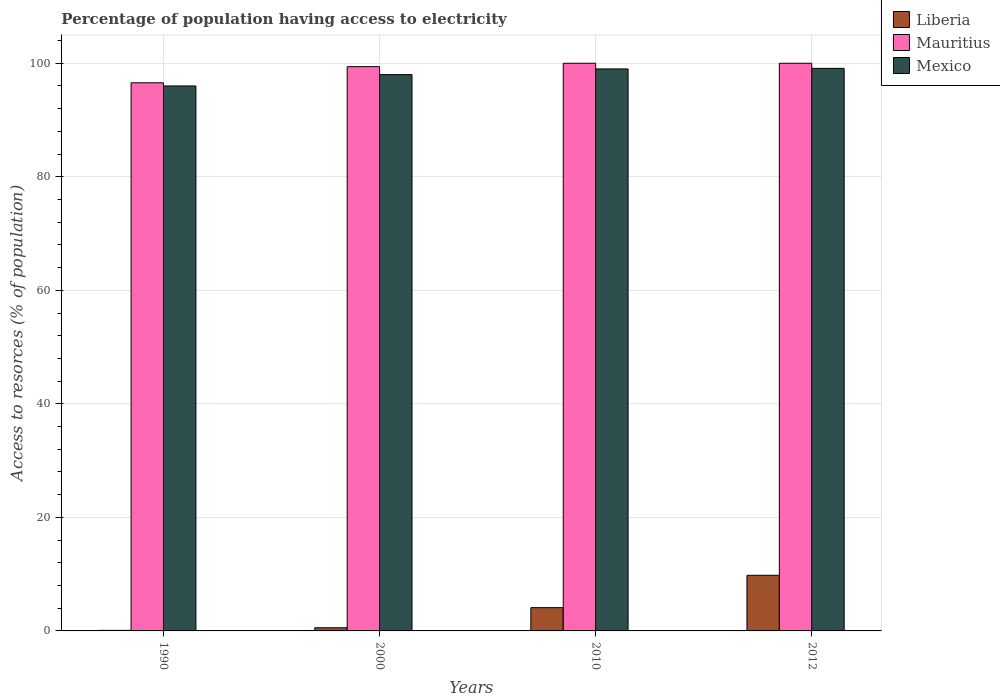How many different coloured bars are there?
Offer a very short reply. 3. How many groups of bars are there?
Provide a short and direct response. 4. Are the number of bars per tick equal to the number of legend labels?
Ensure brevity in your answer.  Yes. Are the number of bars on each tick of the X-axis equal?
Your answer should be compact. Yes. How many bars are there on the 3rd tick from the left?
Ensure brevity in your answer.  3. How many bars are there on the 4th tick from the right?
Keep it short and to the point. 3. What is the label of the 3rd group of bars from the left?
Provide a succinct answer. 2010. What is the percentage of population having access to electricity in Mauritius in 2000?
Make the answer very short. 99.4. Across all years, what is the maximum percentage of population having access to electricity in Mexico?
Make the answer very short. 99.1. Across all years, what is the minimum percentage of population having access to electricity in Mexico?
Give a very brief answer. 96. What is the total percentage of population having access to electricity in Liberia in the graph?
Offer a terse response. 14.56. What is the difference between the percentage of population having access to electricity in Mauritius in 1990 and that in 2012?
Your response must be concise. -3.44. What is the difference between the percentage of population having access to electricity in Mexico in 2010 and the percentage of population having access to electricity in Liberia in 2012?
Offer a terse response. 89.2. What is the average percentage of population having access to electricity in Mexico per year?
Offer a terse response. 98.03. In the year 2010, what is the difference between the percentage of population having access to electricity in Mauritius and percentage of population having access to electricity in Liberia?
Offer a very short reply. 95.9. In how many years, is the percentage of population having access to electricity in Mauritius greater than 32 %?
Your response must be concise. 4. What is the ratio of the percentage of population having access to electricity in Mexico in 2000 to that in 2012?
Your answer should be compact. 0.99. Is the difference between the percentage of population having access to electricity in Mauritius in 1990 and 2010 greater than the difference between the percentage of population having access to electricity in Liberia in 1990 and 2010?
Ensure brevity in your answer.  Yes. What is the difference between the highest and the second highest percentage of population having access to electricity in Mexico?
Your answer should be compact. 0.1. What is the difference between the highest and the lowest percentage of population having access to electricity in Mauritius?
Your answer should be very brief. 3.44. What does the 3rd bar from the right in 2012 represents?
Your answer should be compact. Liberia. How many bars are there?
Ensure brevity in your answer.  12. How many years are there in the graph?
Your answer should be very brief. 4. Does the graph contain grids?
Provide a succinct answer. Yes. How many legend labels are there?
Offer a terse response. 3. What is the title of the graph?
Provide a short and direct response. Percentage of population having access to electricity. Does "Poland" appear as one of the legend labels in the graph?
Provide a short and direct response. No. What is the label or title of the X-axis?
Offer a terse response. Years. What is the label or title of the Y-axis?
Give a very brief answer. Access to resorces (% of population). What is the Access to resorces (% of population) in Mauritius in 1990?
Your answer should be very brief. 96.56. What is the Access to resorces (% of population) of Mexico in 1990?
Provide a succinct answer. 96. What is the Access to resorces (% of population) in Liberia in 2000?
Your answer should be very brief. 0.56. What is the Access to resorces (% of population) in Mauritius in 2000?
Make the answer very short. 99.4. What is the Access to resorces (% of population) in Mexico in 2010?
Your answer should be compact. 99. What is the Access to resorces (% of population) of Liberia in 2012?
Keep it short and to the point. 9.8. What is the Access to resorces (% of population) of Mauritius in 2012?
Keep it short and to the point. 100. What is the Access to resorces (% of population) in Mexico in 2012?
Make the answer very short. 99.1. Across all years, what is the maximum Access to resorces (% of population) of Liberia?
Your answer should be very brief. 9.8. Across all years, what is the maximum Access to resorces (% of population) of Mexico?
Keep it short and to the point. 99.1. Across all years, what is the minimum Access to resorces (% of population) of Liberia?
Offer a terse response. 0.1. Across all years, what is the minimum Access to resorces (% of population) of Mauritius?
Offer a very short reply. 96.56. Across all years, what is the minimum Access to resorces (% of population) of Mexico?
Your response must be concise. 96. What is the total Access to resorces (% of population) of Liberia in the graph?
Make the answer very short. 14.56. What is the total Access to resorces (% of population) in Mauritius in the graph?
Your answer should be compact. 395.96. What is the total Access to resorces (% of population) in Mexico in the graph?
Your answer should be compact. 392.1. What is the difference between the Access to resorces (% of population) of Liberia in 1990 and that in 2000?
Offer a very short reply. -0.46. What is the difference between the Access to resorces (% of population) in Mauritius in 1990 and that in 2000?
Offer a terse response. -2.84. What is the difference between the Access to resorces (% of population) in Mexico in 1990 and that in 2000?
Make the answer very short. -2. What is the difference between the Access to resorces (% of population) in Liberia in 1990 and that in 2010?
Offer a very short reply. -4. What is the difference between the Access to resorces (% of population) in Mauritius in 1990 and that in 2010?
Your answer should be compact. -3.44. What is the difference between the Access to resorces (% of population) of Liberia in 1990 and that in 2012?
Ensure brevity in your answer.  -9.7. What is the difference between the Access to resorces (% of population) of Mauritius in 1990 and that in 2012?
Keep it short and to the point. -3.44. What is the difference between the Access to resorces (% of population) in Mexico in 1990 and that in 2012?
Provide a succinct answer. -3.1. What is the difference between the Access to resorces (% of population) of Liberia in 2000 and that in 2010?
Offer a terse response. -3.54. What is the difference between the Access to resorces (% of population) of Mauritius in 2000 and that in 2010?
Keep it short and to the point. -0.6. What is the difference between the Access to resorces (% of population) of Mexico in 2000 and that in 2010?
Provide a short and direct response. -1. What is the difference between the Access to resorces (% of population) in Liberia in 2000 and that in 2012?
Make the answer very short. -9.24. What is the difference between the Access to resorces (% of population) of Mauritius in 2000 and that in 2012?
Offer a very short reply. -0.6. What is the difference between the Access to resorces (% of population) in Liberia in 1990 and the Access to resorces (% of population) in Mauritius in 2000?
Your answer should be very brief. -99.3. What is the difference between the Access to resorces (% of population) in Liberia in 1990 and the Access to resorces (% of population) in Mexico in 2000?
Your answer should be very brief. -97.9. What is the difference between the Access to resorces (% of population) of Mauritius in 1990 and the Access to resorces (% of population) of Mexico in 2000?
Offer a terse response. -1.44. What is the difference between the Access to resorces (% of population) of Liberia in 1990 and the Access to resorces (% of population) of Mauritius in 2010?
Your answer should be compact. -99.9. What is the difference between the Access to resorces (% of population) in Liberia in 1990 and the Access to resorces (% of population) in Mexico in 2010?
Your response must be concise. -98.9. What is the difference between the Access to resorces (% of population) in Mauritius in 1990 and the Access to resorces (% of population) in Mexico in 2010?
Offer a very short reply. -2.44. What is the difference between the Access to resorces (% of population) in Liberia in 1990 and the Access to resorces (% of population) in Mauritius in 2012?
Give a very brief answer. -99.9. What is the difference between the Access to resorces (% of population) in Liberia in 1990 and the Access to resorces (% of population) in Mexico in 2012?
Provide a short and direct response. -99. What is the difference between the Access to resorces (% of population) of Mauritius in 1990 and the Access to resorces (% of population) of Mexico in 2012?
Make the answer very short. -2.54. What is the difference between the Access to resorces (% of population) of Liberia in 2000 and the Access to resorces (% of population) of Mauritius in 2010?
Offer a terse response. -99.44. What is the difference between the Access to resorces (% of population) in Liberia in 2000 and the Access to resorces (% of population) in Mexico in 2010?
Ensure brevity in your answer.  -98.44. What is the difference between the Access to resorces (% of population) in Liberia in 2000 and the Access to resorces (% of population) in Mauritius in 2012?
Your response must be concise. -99.44. What is the difference between the Access to resorces (% of population) in Liberia in 2000 and the Access to resorces (% of population) in Mexico in 2012?
Offer a very short reply. -98.54. What is the difference between the Access to resorces (% of population) of Liberia in 2010 and the Access to resorces (% of population) of Mauritius in 2012?
Keep it short and to the point. -95.9. What is the difference between the Access to resorces (% of population) of Liberia in 2010 and the Access to resorces (% of population) of Mexico in 2012?
Your answer should be very brief. -95. What is the difference between the Access to resorces (% of population) of Mauritius in 2010 and the Access to resorces (% of population) of Mexico in 2012?
Make the answer very short. 0.9. What is the average Access to resorces (% of population) of Liberia per year?
Your answer should be compact. 3.64. What is the average Access to resorces (% of population) of Mauritius per year?
Give a very brief answer. 98.99. What is the average Access to resorces (% of population) of Mexico per year?
Provide a short and direct response. 98.03. In the year 1990, what is the difference between the Access to resorces (% of population) in Liberia and Access to resorces (% of population) in Mauritius?
Offer a very short reply. -96.46. In the year 1990, what is the difference between the Access to resorces (% of population) in Liberia and Access to resorces (% of population) in Mexico?
Provide a succinct answer. -95.9. In the year 1990, what is the difference between the Access to resorces (% of population) in Mauritius and Access to resorces (% of population) in Mexico?
Ensure brevity in your answer.  0.56. In the year 2000, what is the difference between the Access to resorces (% of population) in Liberia and Access to resorces (% of population) in Mauritius?
Make the answer very short. -98.84. In the year 2000, what is the difference between the Access to resorces (% of population) of Liberia and Access to resorces (% of population) of Mexico?
Provide a short and direct response. -97.44. In the year 2000, what is the difference between the Access to resorces (% of population) of Mauritius and Access to resorces (% of population) of Mexico?
Provide a succinct answer. 1.4. In the year 2010, what is the difference between the Access to resorces (% of population) of Liberia and Access to resorces (% of population) of Mauritius?
Make the answer very short. -95.9. In the year 2010, what is the difference between the Access to resorces (% of population) of Liberia and Access to resorces (% of population) of Mexico?
Ensure brevity in your answer.  -94.9. In the year 2010, what is the difference between the Access to resorces (% of population) in Mauritius and Access to resorces (% of population) in Mexico?
Your answer should be very brief. 1. In the year 2012, what is the difference between the Access to resorces (% of population) in Liberia and Access to resorces (% of population) in Mauritius?
Your answer should be compact. -90.2. In the year 2012, what is the difference between the Access to resorces (% of population) in Liberia and Access to resorces (% of population) in Mexico?
Keep it short and to the point. -89.3. What is the ratio of the Access to resorces (% of population) in Liberia in 1990 to that in 2000?
Offer a terse response. 0.18. What is the ratio of the Access to resorces (% of population) in Mauritius in 1990 to that in 2000?
Make the answer very short. 0.97. What is the ratio of the Access to resorces (% of population) of Mexico in 1990 to that in 2000?
Provide a succinct answer. 0.98. What is the ratio of the Access to resorces (% of population) of Liberia in 1990 to that in 2010?
Give a very brief answer. 0.02. What is the ratio of the Access to resorces (% of population) in Mauritius in 1990 to that in 2010?
Offer a terse response. 0.97. What is the ratio of the Access to resorces (% of population) of Mexico in 1990 to that in 2010?
Offer a terse response. 0.97. What is the ratio of the Access to resorces (% of population) in Liberia in 1990 to that in 2012?
Provide a succinct answer. 0.01. What is the ratio of the Access to resorces (% of population) of Mauritius in 1990 to that in 2012?
Provide a short and direct response. 0.97. What is the ratio of the Access to resorces (% of population) of Mexico in 1990 to that in 2012?
Provide a short and direct response. 0.97. What is the ratio of the Access to resorces (% of population) of Liberia in 2000 to that in 2010?
Your response must be concise. 0.14. What is the ratio of the Access to resorces (% of population) of Mauritius in 2000 to that in 2010?
Give a very brief answer. 0.99. What is the ratio of the Access to resorces (% of population) in Liberia in 2000 to that in 2012?
Make the answer very short. 0.06. What is the ratio of the Access to resorces (% of population) of Mauritius in 2000 to that in 2012?
Provide a succinct answer. 0.99. What is the ratio of the Access to resorces (% of population) of Mexico in 2000 to that in 2012?
Your answer should be very brief. 0.99. What is the ratio of the Access to resorces (% of population) in Liberia in 2010 to that in 2012?
Offer a very short reply. 0.42. What is the difference between the highest and the lowest Access to resorces (% of population) of Mauritius?
Make the answer very short. 3.44. What is the difference between the highest and the lowest Access to resorces (% of population) of Mexico?
Keep it short and to the point. 3.1. 